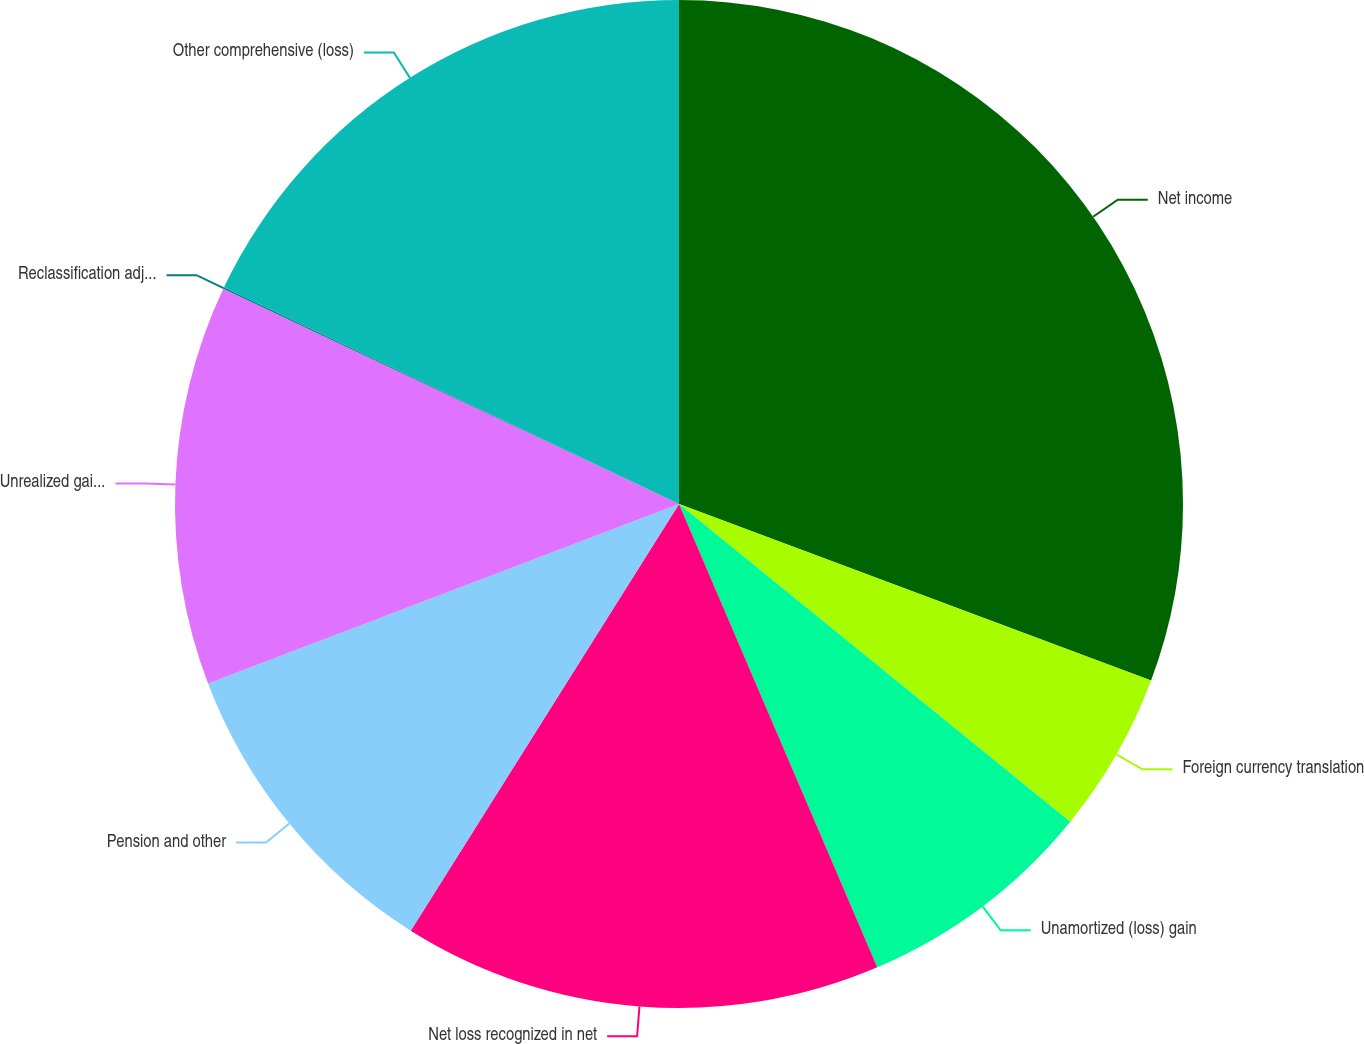Convert chart to OTSL. <chart><loc_0><loc_0><loc_500><loc_500><pie_chart><fcel>Net income<fcel>Foreign currency translation<fcel>Unamortized (loss) gain<fcel>Net loss recognized in net<fcel>Pension and other<fcel>Unrealized gain (loss) on<fcel>Reclassification adjustment on<fcel>Other comprehensive (loss)<nl><fcel>30.7%<fcel>5.16%<fcel>7.71%<fcel>15.37%<fcel>10.27%<fcel>12.82%<fcel>0.05%<fcel>17.93%<nl></chart> 